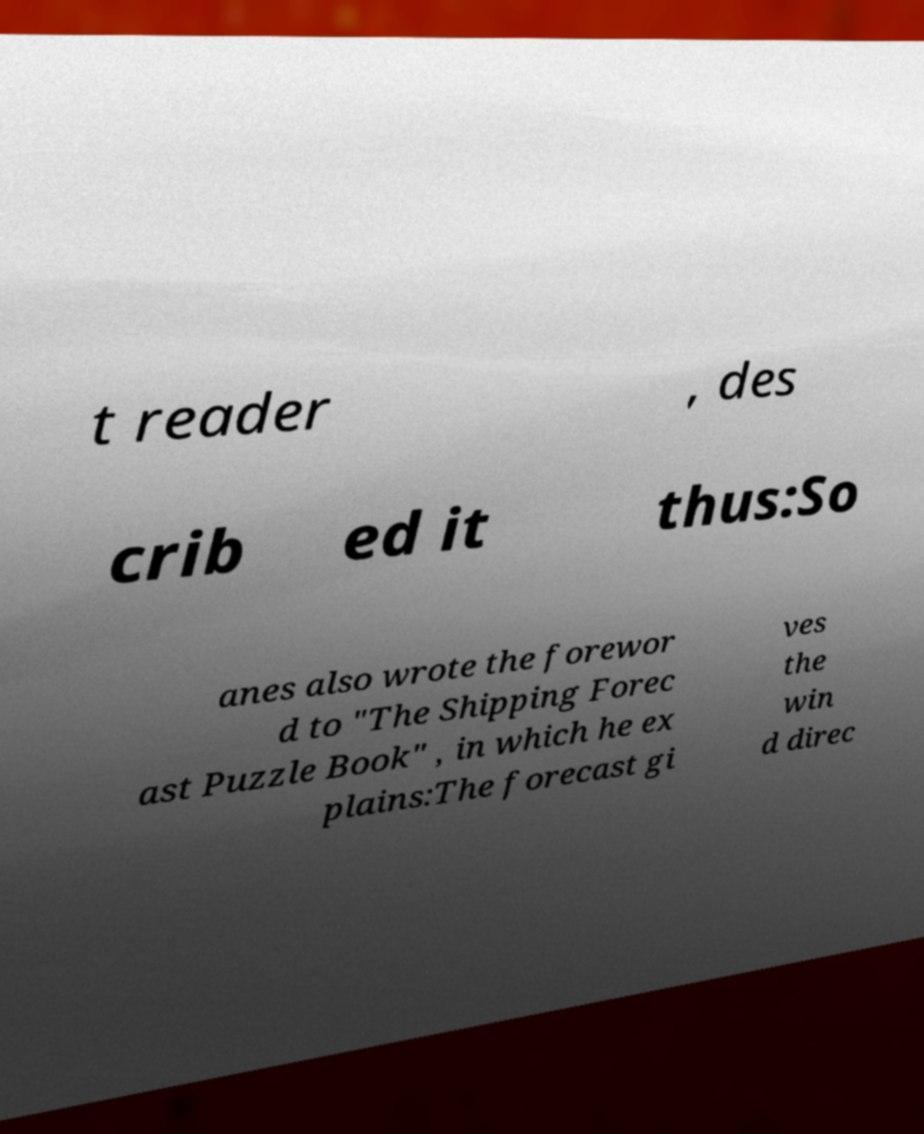For documentation purposes, I need the text within this image transcribed. Could you provide that? t reader , des crib ed it thus:So anes also wrote the forewor d to "The Shipping Forec ast Puzzle Book" , in which he ex plains:The forecast gi ves the win d direc 